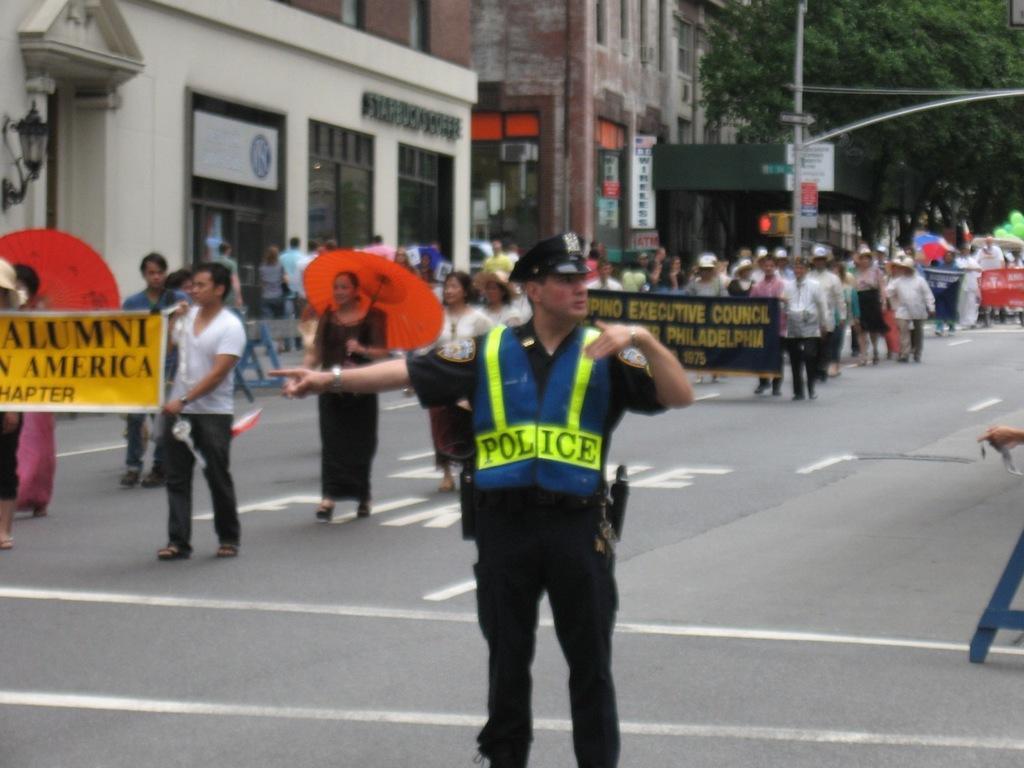Can you describe this image briefly? In this image in the middle, there is a man, he wears a shirt, trouser, cap, he is standing. On the left there is a man, he wears a white t shirt, trouser, he is holding a poster, behind him there is a woman, she wears a dress, she is holding an umbrella. In the middle there are many people, buildings, poles, posters, balloons, trees and road. 